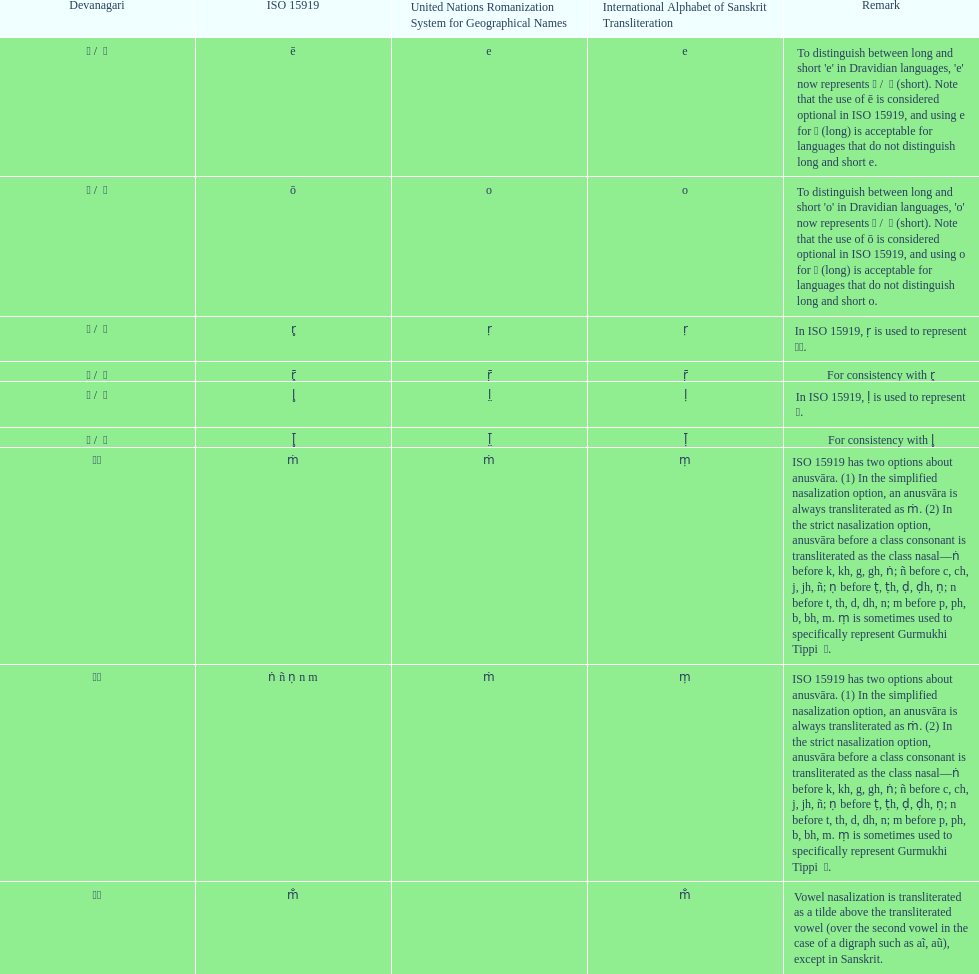Give me the full table as a dictionary. {'header': ['Devanagari', 'ISO 15919', 'United Nations Romanization System for Geographical Names', 'International Alphabet of Sanskrit Transliteration', 'Remark'], 'rows': [['ए / \xa0े', 'ē', 'e', 'e', "To distinguish between long and short 'e' in Dravidian languages, 'e' now represents ऎ / \xa0ॆ (short). Note that the use of ē is considered optional in ISO 15919, and using e for ए (long) is acceptable for languages that do not distinguish long and short e."], ['ओ / \xa0ो', 'ō', 'o', 'o', "To distinguish between long and short 'o' in Dravidian languages, 'o' now represents ऒ / \xa0ॊ (short). Note that the use of ō is considered optional in ISO 15919, and using o for ओ (long) is acceptable for languages that do not distinguish long and short o."], ['ऋ / \xa0ृ', 'r̥', 'ṛ', 'ṛ', 'In ISO 15919, ṛ is used to represent ड़.'], ['ॠ / \xa0ॄ', 'r̥̄', 'ṝ', 'ṝ', 'For consistency with r̥'], ['ऌ / \xa0ॢ', 'l̥', 'l̤', 'ḷ', 'In ISO 15919, ḷ is used to represent ळ.'], ['ॡ / \xa0ॣ', 'l̥̄', 'l̤̄', 'ḹ', 'For consistency with l̥'], ['◌ं', 'ṁ', 'ṁ', 'ṃ', 'ISO 15919 has two options about anusvāra. (1) In the simplified nasalization option, an anusvāra is always transliterated as ṁ. (2) In the strict nasalization option, anusvāra before a class consonant is transliterated as the class nasal—ṅ before k, kh, g, gh, ṅ; ñ before c, ch, j, jh, ñ; ṇ before ṭ, ṭh, ḍ, ḍh, ṇ; n before t, th, d, dh, n; m before p, ph, b, bh, m. ṃ is sometimes used to specifically represent Gurmukhi Tippi \xa0ੰ.'], ['◌ं', 'ṅ ñ ṇ n m', 'ṁ', 'ṃ', 'ISO 15919 has two options about anusvāra. (1) In the simplified nasalization option, an anusvāra is always transliterated as ṁ. (2) In the strict nasalization option, anusvāra before a class consonant is transliterated as the class nasal—ṅ before k, kh, g, gh, ṅ; ñ before c, ch, j, jh, ñ; ṇ before ṭ, ṭh, ḍ, ḍh, ṇ; n before t, th, d, dh, n; m before p, ph, b, bh, m. ṃ is sometimes used to specifically represent Gurmukhi Tippi \xa0ੰ.'], ['◌ँ', 'm̐', '', 'm̐', 'Vowel nasalization is transliterated as a tilde above the transliterated vowel (over the second vowel in the case of a digraph such as aĩ, aũ), except in Sanskrit.']]} Which iast comes prior to the letter o? E. 